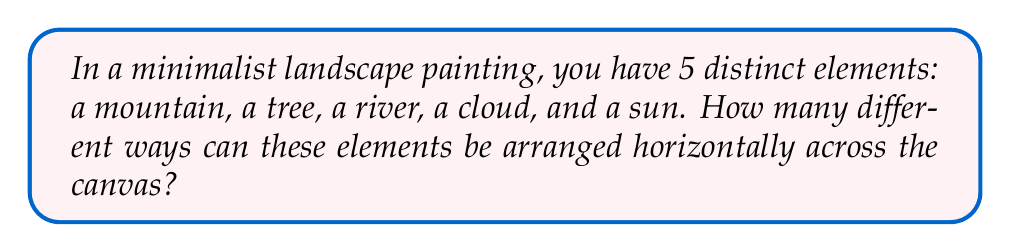Can you answer this question? To solve this problem, we need to consider the fundamental principle of counting, specifically permutations. Here's a step-by-step explanation:

1) We have 5 distinct elements, and we want to arrange all of them.

2) This scenario is a perfect example of a permutation without repetition.

3) The formula for permutations of n distinct objects is:

   $$P(n) = n!$$

   Where $n!$ represents the factorial of $n$.

4) In this case, $n = 5$ (mountain, tree, river, cloud, sun).

5) Therefore, the number of possible arrangements is:

   $$P(5) = 5!$$

6) Let's calculate 5!:
   
   $$5! = 5 \times 4 \times 3 \times 2 \times 1 = 120$$

Thus, there are 120 different ways to arrange these 5 minimalist landscape elements horizontally across the canvas.
Answer: 120 